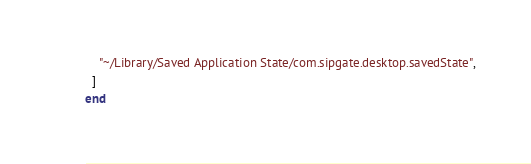<code> <loc_0><loc_0><loc_500><loc_500><_Ruby_>    "~/Library/Saved Application State/com.sipgate.desktop.savedState",
  ]
end
</code> 